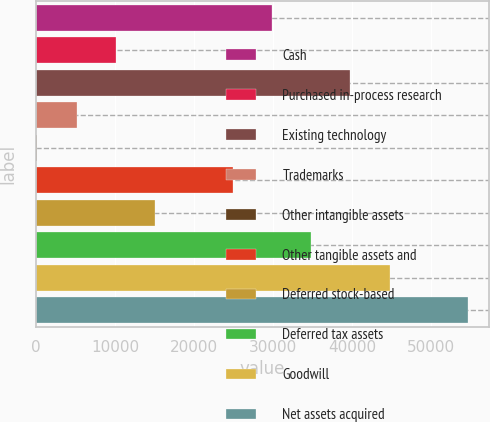Convert chart to OTSL. <chart><loc_0><loc_0><loc_500><loc_500><bar_chart><fcel>Cash<fcel>Purchased in-process research<fcel>Existing technology<fcel>Trademarks<fcel>Other intangible assets<fcel>Other tangible assets and<fcel>Deferred stock-based<fcel>Deferred tax assets<fcel>Goodwill<fcel>Net assets acquired<nl><fcel>29882.6<fcel>10094.2<fcel>39776.8<fcel>5147.1<fcel>200<fcel>24935.5<fcel>15041.3<fcel>34829.7<fcel>44723.9<fcel>54618.1<nl></chart> 